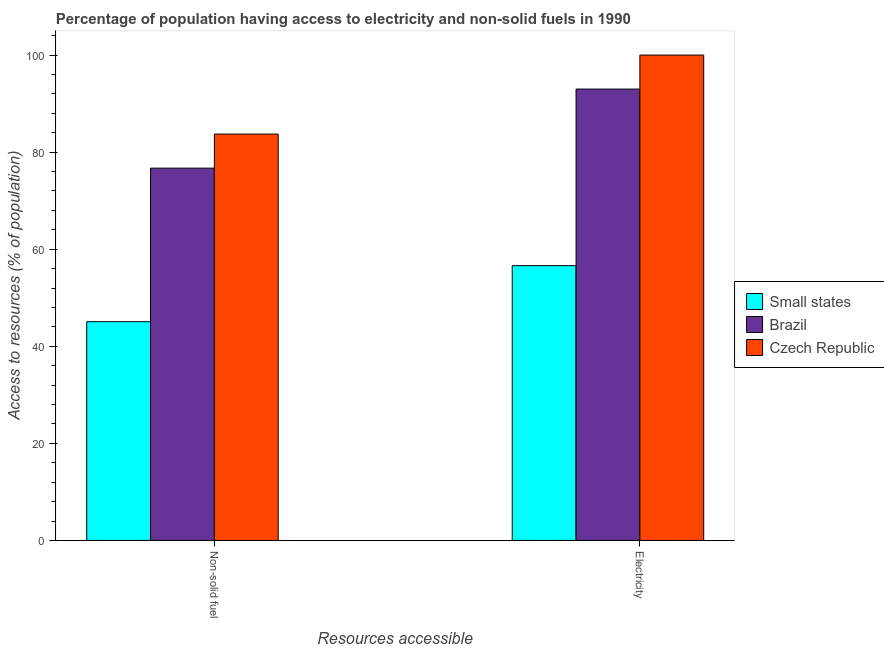Are the number of bars on each tick of the X-axis equal?
Your answer should be compact. Yes. How many bars are there on the 2nd tick from the left?
Provide a succinct answer. 3. How many bars are there on the 1st tick from the right?
Provide a short and direct response. 3. What is the label of the 1st group of bars from the left?
Offer a very short reply. Non-solid fuel. What is the percentage of population having access to non-solid fuel in Small states?
Your response must be concise. 45.07. Across all countries, what is the minimum percentage of population having access to non-solid fuel?
Offer a terse response. 45.07. In which country was the percentage of population having access to non-solid fuel maximum?
Make the answer very short. Czech Republic. In which country was the percentage of population having access to non-solid fuel minimum?
Offer a very short reply. Small states. What is the total percentage of population having access to electricity in the graph?
Your answer should be very brief. 249.61. What is the difference between the percentage of population having access to non-solid fuel in Czech Republic and that in Brazil?
Provide a succinct answer. 7.02. What is the difference between the percentage of population having access to non-solid fuel in Czech Republic and the percentage of population having access to electricity in Brazil?
Provide a succinct answer. -9.27. What is the average percentage of population having access to non-solid fuel per country?
Offer a terse response. 68.5. What is the difference between the percentage of population having access to non-solid fuel and percentage of population having access to electricity in Brazil?
Your answer should be compact. -16.29. What is the ratio of the percentage of population having access to electricity in Czech Republic to that in Brazil?
Your answer should be very brief. 1.08. Is the percentage of population having access to electricity in Brazil less than that in Small states?
Make the answer very short. No. In how many countries, is the percentage of population having access to electricity greater than the average percentage of population having access to electricity taken over all countries?
Your answer should be very brief. 2. What does the 3rd bar from the left in Electricity represents?
Make the answer very short. Czech Republic. What does the 2nd bar from the right in Non-solid fuel represents?
Your response must be concise. Brazil. What is the difference between two consecutive major ticks on the Y-axis?
Provide a succinct answer. 20. Does the graph contain any zero values?
Your response must be concise. No. Where does the legend appear in the graph?
Your answer should be very brief. Center right. What is the title of the graph?
Your answer should be very brief. Percentage of population having access to electricity and non-solid fuels in 1990. What is the label or title of the X-axis?
Offer a terse response. Resources accessible. What is the label or title of the Y-axis?
Provide a short and direct response. Access to resources (% of population). What is the Access to resources (% of population) of Small states in Non-solid fuel?
Keep it short and to the point. 45.07. What is the Access to resources (% of population) in Brazil in Non-solid fuel?
Your answer should be compact. 76.71. What is the Access to resources (% of population) of Czech Republic in Non-solid fuel?
Ensure brevity in your answer.  83.73. What is the Access to resources (% of population) in Small states in Electricity?
Offer a terse response. 56.61. What is the Access to resources (% of population) in Brazil in Electricity?
Keep it short and to the point. 93. Across all Resources accessible, what is the maximum Access to resources (% of population) of Small states?
Your response must be concise. 56.61. Across all Resources accessible, what is the maximum Access to resources (% of population) of Brazil?
Ensure brevity in your answer.  93. Across all Resources accessible, what is the minimum Access to resources (% of population) of Small states?
Make the answer very short. 45.07. Across all Resources accessible, what is the minimum Access to resources (% of population) of Brazil?
Give a very brief answer. 76.71. Across all Resources accessible, what is the minimum Access to resources (% of population) in Czech Republic?
Your answer should be compact. 83.73. What is the total Access to resources (% of population) in Small states in the graph?
Ensure brevity in your answer.  101.69. What is the total Access to resources (% of population) of Brazil in the graph?
Ensure brevity in your answer.  169.71. What is the total Access to resources (% of population) of Czech Republic in the graph?
Your answer should be very brief. 183.73. What is the difference between the Access to resources (% of population) of Small states in Non-solid fuel and that in Electricity?
Make the answer very short. -11.54. What is the difference between the Access to resources (% of population) in Brazil in Non-solid fuel and that in Electricity?
Offer a terse response. -16.29. What is the difference between the Access to resources (% of population) of Czech Republic in Non-solid fuel and that in Electricity?
Make the answer very short. -16.27. What is the difference between the Access to resources (% of population) in Small states in Non-solid fuel and the Access to resources (% of population) in Brazil in Electricity?
Offer a very short reply. -47.93. What is the difference between the Access to resources (% of population) in Small states in Non-solid fuel and the Access to resources (% of population) in Czech Republic in Electricity?
Your response must be concise. -54.93. What is the difference between the Access to resources (% of population) in Brazil in Non-solid fuel and the Access to resources (% of population) in Czech Republic in Electricity?
Give a very brief answer. -23.29. What is the average Access to resources (% of population) of Small states per Resources accessible?
Your answer should be compact. 50.84. What is the average Access to resources (% of population) in Brazil per Resources accessible?
Offer a very short reply. 84.85. What is the average Access to resources (% of population) in Czech Republic per Resources accessible?
Offer a very short reply. 91.86. What is the difference between the Access to resources (% of population) of Small states and Access to resources (% of population) of Brazil in Non-solid fuel?
Your response must be concise. -31.63. What is the difference between the Access to resources (% of population) in Small states and Access to resources (% of population) in Czech Republic in Non-solid fuel?
Offer a terse response. -38.65. What is the difference between the Access to resources (% of population) of Brazil and Access to resources (% of population) of Czech Republic in Non-solid fuel?
Provide a short and direct response. -7.02. What is the difference between the Access to resources (% of population) in Small states and Access to resources (% of population) in Brazil in Electricity?
Give a very brief answer. -36.39. What is the difference between the Access to resources (% of population) of Small states and Access to resources (% of population) of Czech Republic in Electricity?
Your response must be concise. -43.39. What is the difference between the Access to resources (% of population) of Brazil and Access to resources (% of population) of Czech Republic in Electricity?
Provide a short and direct response. -7. What is the ratio of the Access to resources (% of population) in Small states in Non-solid fuel to that in Electricity?
Offer a terse response. 0.8. What is the ratio of the Access to resources (% of population) in Brazil in Non-solid fuel to that in Electricity?
Keep it short and to the point. 0.82. What is the ratio of the Access to resources (% of population) in Czech Republic in Non-solid fuel to that in Electricity?
Ensure brevity in your answer.  0.84. What is the difference between the highest and the second highest Access to resources (% of population) in Small states?
Your answer should be compact. 11.54. What is the difference between the highest and the second highest Access to resources (% of population) of Brazil?
Provide a succinct answer. 16.29. What is the difference between the highest and the second highest Access to resources (% of population) of Czech Republic?
Provide a succinct answer. 16.27. What is the difference between the highest and the lowest Access to resources (% of population) of Small states?
Your answer should be compact. 11.54. What is the difference between the highest and the lowest Access to resources (% of population) of Brazil?
Your response must be concise. 16.29. What is the difference between the highest and the lowest Access to resources (% of population) in Czech Republic?
Make the answer very short. 16.27. 